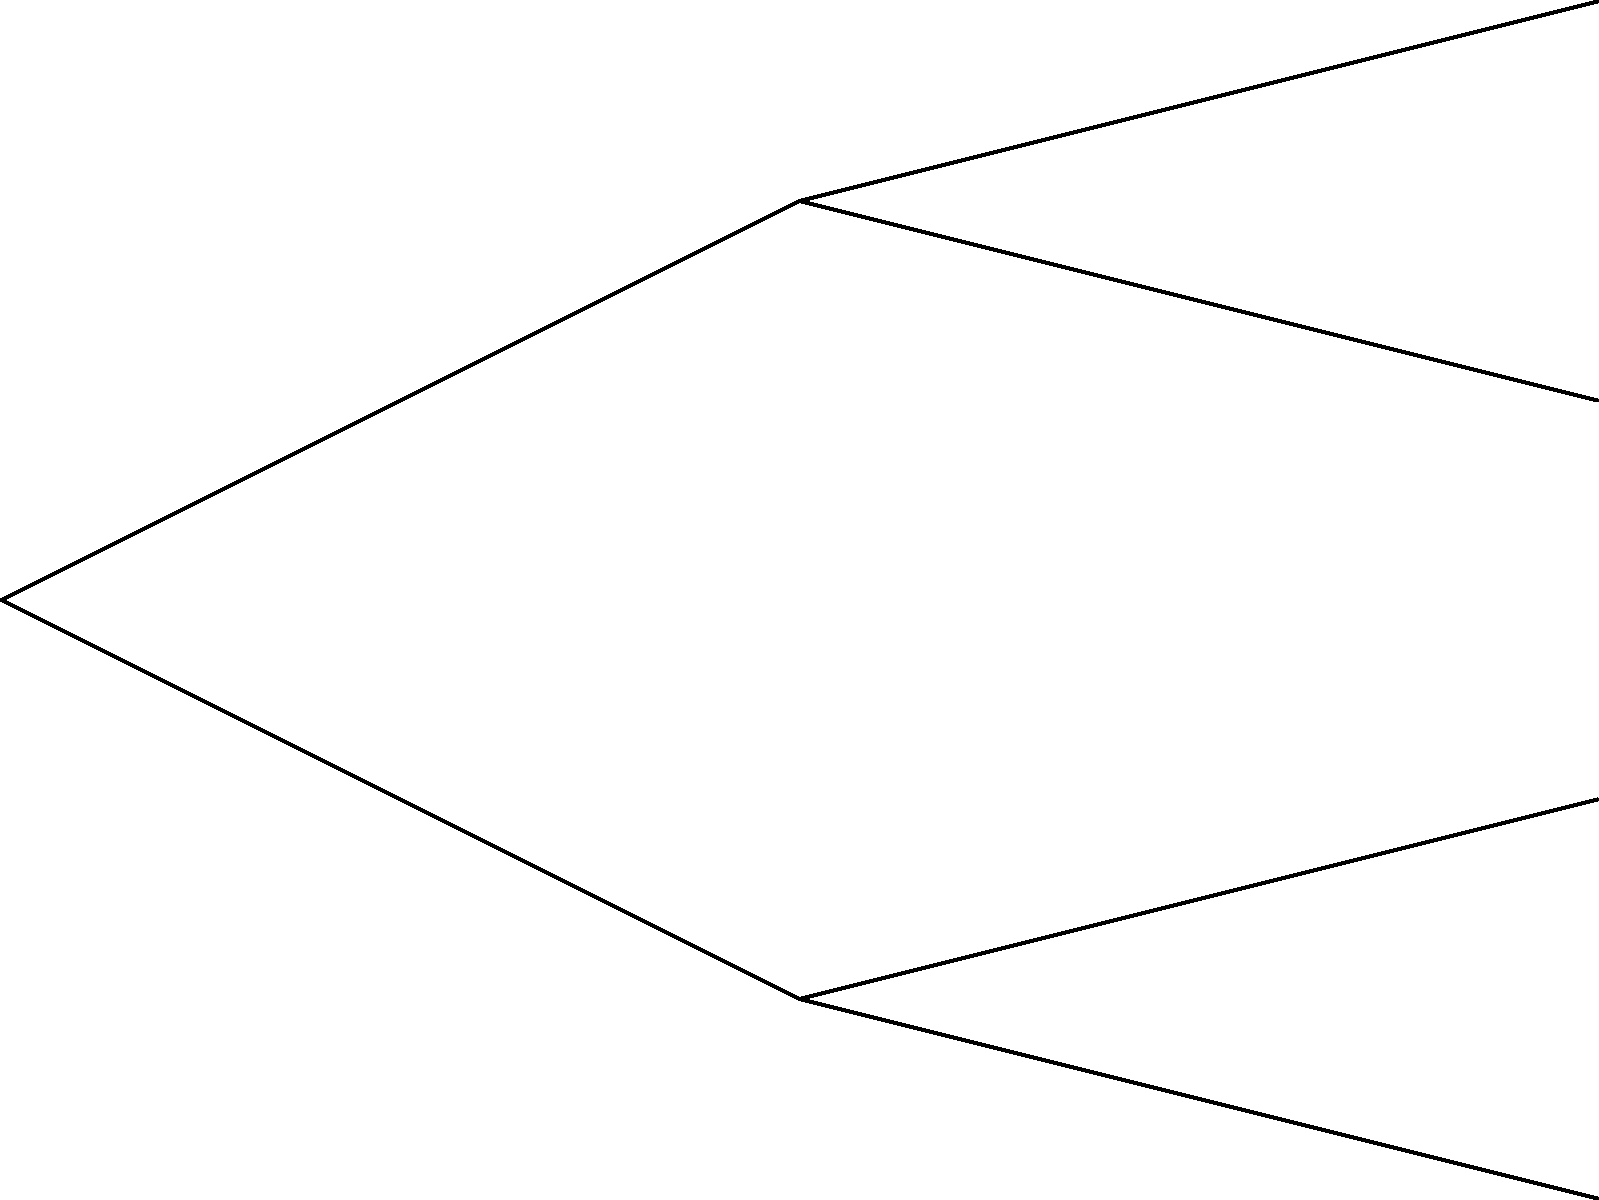As an energy company executive, you are considering implementing emission reduction technologies. The decision tree above shows the potential outcomes based on market demand. The cost of implementation is $20 million. What is the expected value of implementing the new technologies, and should you proceed with the implementation? To solve this problem, we need to calculate the expected value of implementing the new technologies and compare it to the expected value of not implementing them.

Step 1: Calculate the expected value of implementing the technologies.
- High Demand (60%): $80M
- Low Demand (40%): $30M
Expected Value = (0.60 × $80M) + (0.40 × $30M) = $48M + $12M = $60M

Step 2: Subtract the implementation cost.
Net Expected Value = $60M - $20M = $40M

Step 3: Calculate the expected value of not implementing the technologies.
- High Demand (60%): $100M
- Low Demand (40%): $50M
Expected Value = (0.60 × $100M) + (0.40 × $50M) = $60M + $20M = $80M

Step 4: Compare the two options.
- Implementing: $40M (after costs)
- Not implementing: $80M

Step 5: Make a decision based on expected value.
Since not implementing the technologies has a higher expected value ($80M vs $40M), the decision should be to not implement the emission reduction technologies.
Answer: Do not implement; expected value without implementation ($80M) exceeds implementation ($40M). 